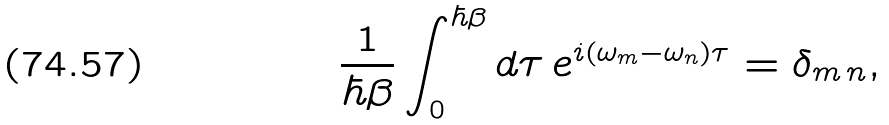<formula> <loc_0><loc_0><loc_500><loc_500>\frac { 1 } { \hbar { \beta } } \int _ { 0 } ^ { \hbar { \beta } } d \tau \, e ^ { i ( \omega _ { m } - \omega _ { n } ) \tau } = \delta _ { m \, n } ,</formula> 